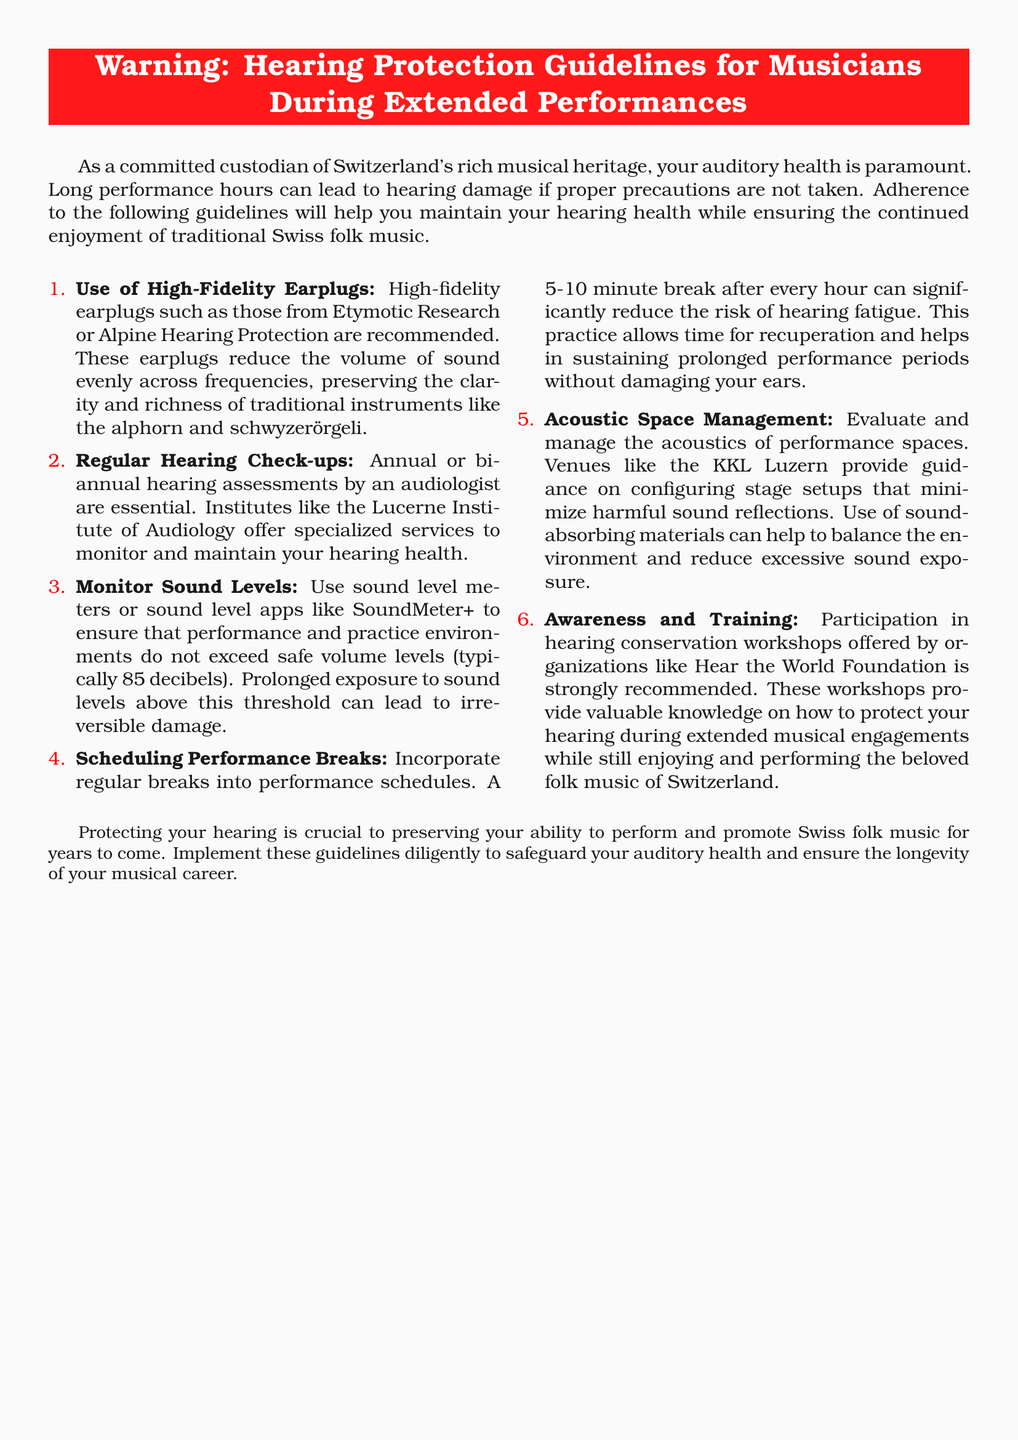What type of earplugs is recommended? The document specifies the use of high-fidelity earplugs to protect hearing.
Answer: High-Fidelity Earplugs What is the suggested frequency for hearing check-ups? The document advises annual or bi-annual assessments for effective monitoring of hearing health.
Answer: Annual or bi-annual What is the maximum safe volume level in decibels? The document states that sound levels should not exceed 85 decibels to prevent hearing damage.
Answer: 85 decibels What is the recommended duration for breaks during performances? The document suggests taking breaks of 5-10 minutes after every hour of performance.
Answer: 5-10 minutes Which venue is mentioned for acoustic space management? The document refers to a specific venue providing guidance on stage setups that minimize harmful sound reflections.
Answer: KKL Luzern What organization's workshops are recommended for hearing conservation? The document recommends participation in workshops from an organization focused on hearing protection.
Answer: Hear the World Foundation What is the primary concern emphasized in the document? The document highlights the importance of auditory health during performances to prevent hearing damage.
Answer: Auditory health 